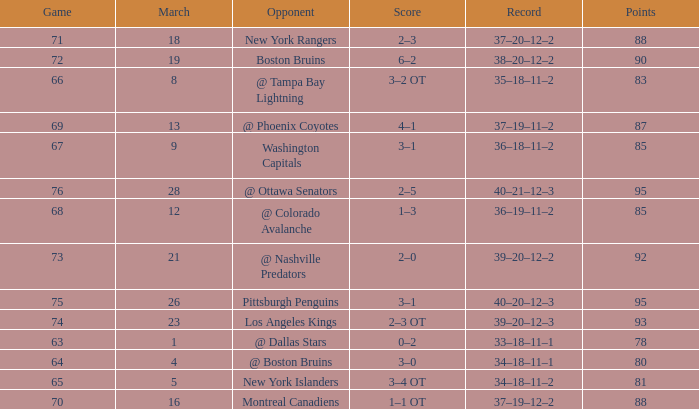Which Game is the highest one that has Points smaller than 92, and a Score of 1–3? 68.0. 